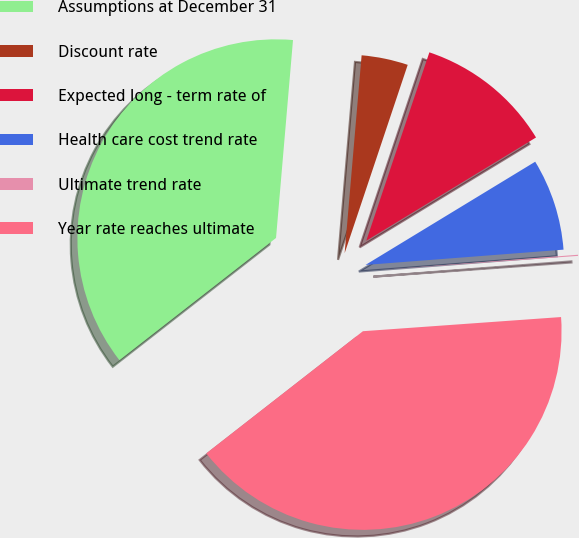Convert chart. <chart><loc_0><loc_0><loc_500><loc_500><pie_chart><fcel>Assumptions at December 31<fcel>Discount rate<fcel>Expected long - term rate of<fcel>Health care cost trend rate<fcel>Ultimate trend rate<fcel>Year rate reaches ultimate<nl><fcel>36.9%<fcel>3.78%<fcel>11.16%<fcel>7.47%<fcel>0.09%<fcel>40.59%<nl></chart> 